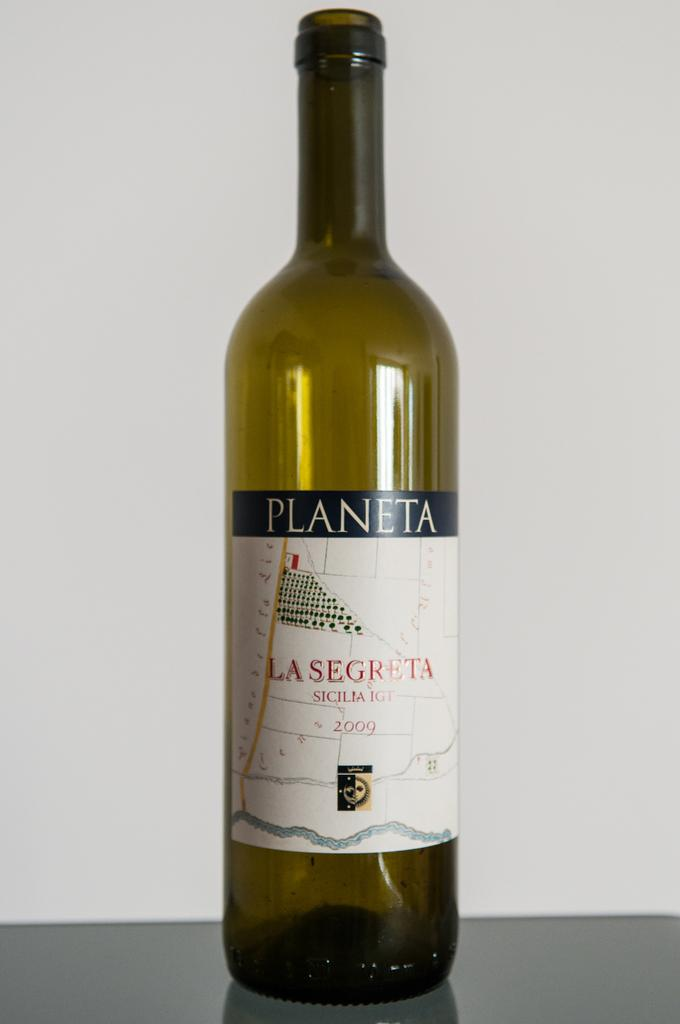<image>
Describe the image concisely. A bottle of Planeta La Segreta Sicilia IGT 2009 wine. 